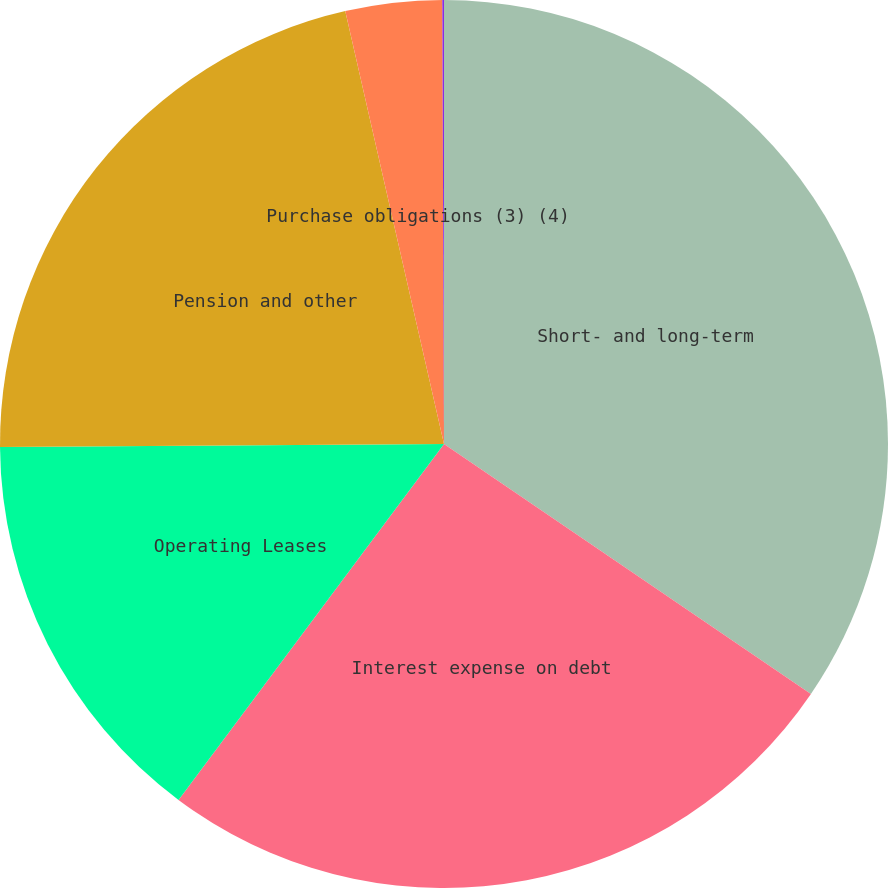Convert chart. <chart><loc_0><loc_0><loc_500><loc_500><pie_chart><fcel>Short- and long-term<fcel>Interest expense on debt<fcel>Operating Leases<fcel>Pension and other<fcel>Purchase obligations (3) (4)<fcel>Other (5)<nl><fcel>34.52%<fcel>25.68%<fcel>14.69%<fcel>21.54%<fcel>3.51%<fcel>0.06%<nl></chart> 